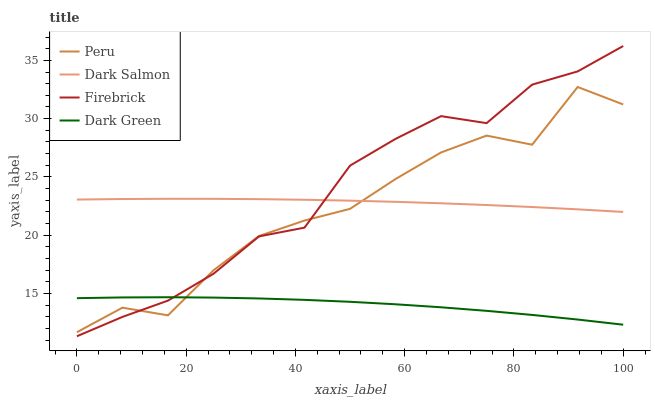Does Dark Green have the minimum area under the curve?
Answer yes or no. Yes. Does Firebrick have the maximum area under the curve?
Answer yes or no. Yes. Does Dark Salmon have the minimum area under the curve?
Answer yes or no. No. Does Dark Salmon have the maximum area under the curve?
Answer yes or no. No. Is Dark Salmon the smoothest?
Answer yes or no. Yes. Is Peru the roughest?
Answer yes or no. Yes. Is Peru the smoothest?
Answer yes or no. No. Is Dark Salmon the roughest?
Answer yes or no. No. Does Firebrick have the lowest value?
Answer yes or no. Yes. Does Peru have the lowest value?
Answer yes or no. No. Does Firebrick have the highest value?
Answer yes or no. Yes. Does Dark Salmon have the highest value?
Answer yes or no. No. Is Dark Green less than Dark Salmon?
Answer yes or no. Yes. Is Dark Salmon greater than Dark Green?
Answer yes or no. Yes. Does Firebrick intersect Peru?
Answer yes or no. Yes. Is Firebrick less than Peru?
Answer yes or no. No. Is Firebrick greater than Peru?
Answer yes or no. No. Does Dark Green intersect Dark Salmon?
Answer yes or no. No. 